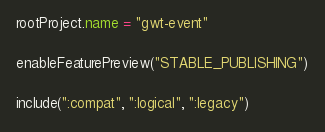Convert code to text. <code><loc_0><loc_0><loc_500><loc_500><_Kotlin_>rootProject.name = "gwt-event"

enableFeaturePreview("STABLE_PUBLISHING")

include(":compat", ":logical", ":legacy")
</code> 